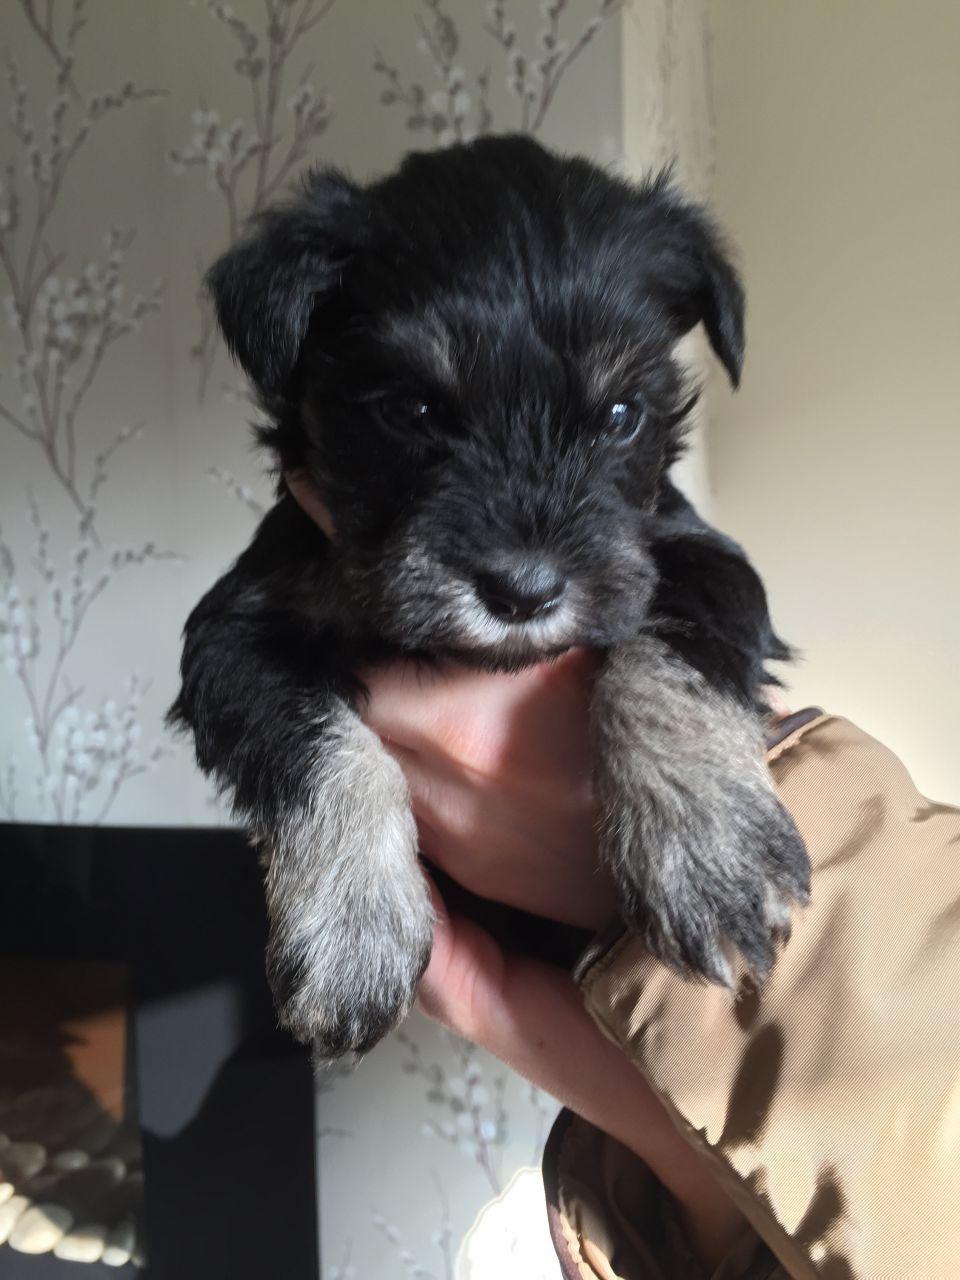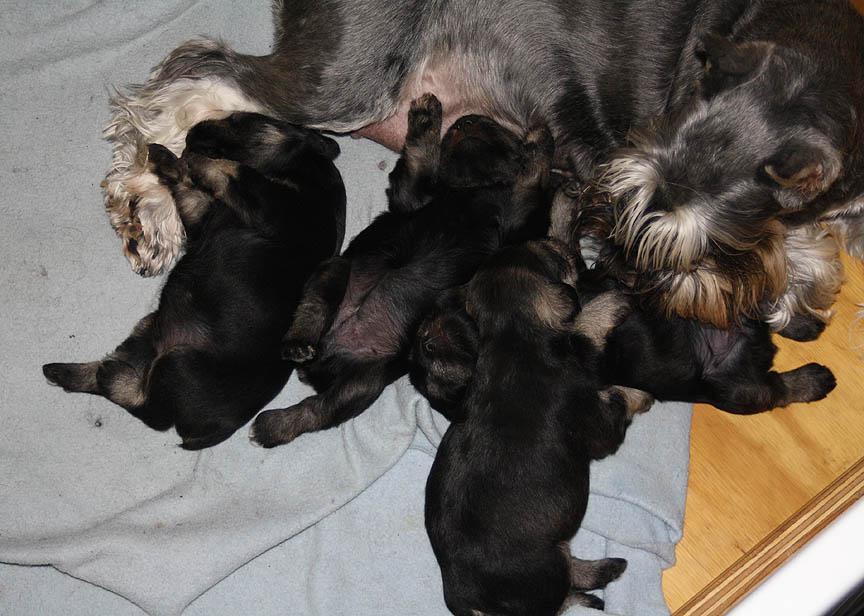The first image is the image on the left, the second image is the image on the right. Analyze the images presented: Is the assertion "There is a single puppy being held in the air in one image." valid? Answer yes or no. Yes. The first image is the image on the left, the second image is the image on the right. For the images shown, is this caption "A human is holding the puppy in the image on the right." true? Answer yes or no. No. 